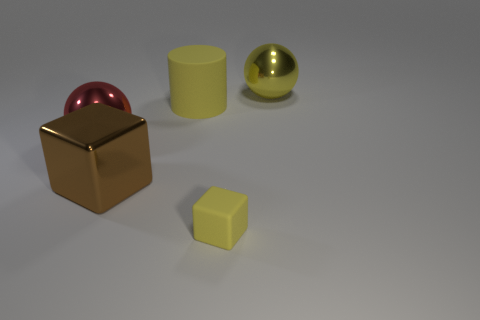There is a yellow matte object to the right of the yellow matte cylinder; what size is it?
Provide a short and direct response. Small. What number of large things are either purple objects or yellow metal spheres?
Your answer should be very brief. 1. What is the color of the object that is both in front of the big red object and to the left of the tiny yellow rubber thing?
Your answer should be compact. Brown. Are there any other yellow matte objects of the same shape as the small yellow thing?
Keep it short and to the point. No. What material is the yellow sphere?
Your answer should be compact. Metal. There is a small yellow rubber thing; are there any small yellow rubber objects in front of it?
Offer a very short reply. No. Does the big red metal object have the same shape as the large yellow metallic thing?
Offer a very short reply. Yes. What number of other objects are there of the same size as the yellow rubber block?
Keep it short and to the point. 0. What number of things are brown shiny cubes that are in front of the large yellow matte cylinder or small cyan matte blocks?
Offer a very short reply. 1. The big metal block is what color?
Provide a short and direct response. Brown. 